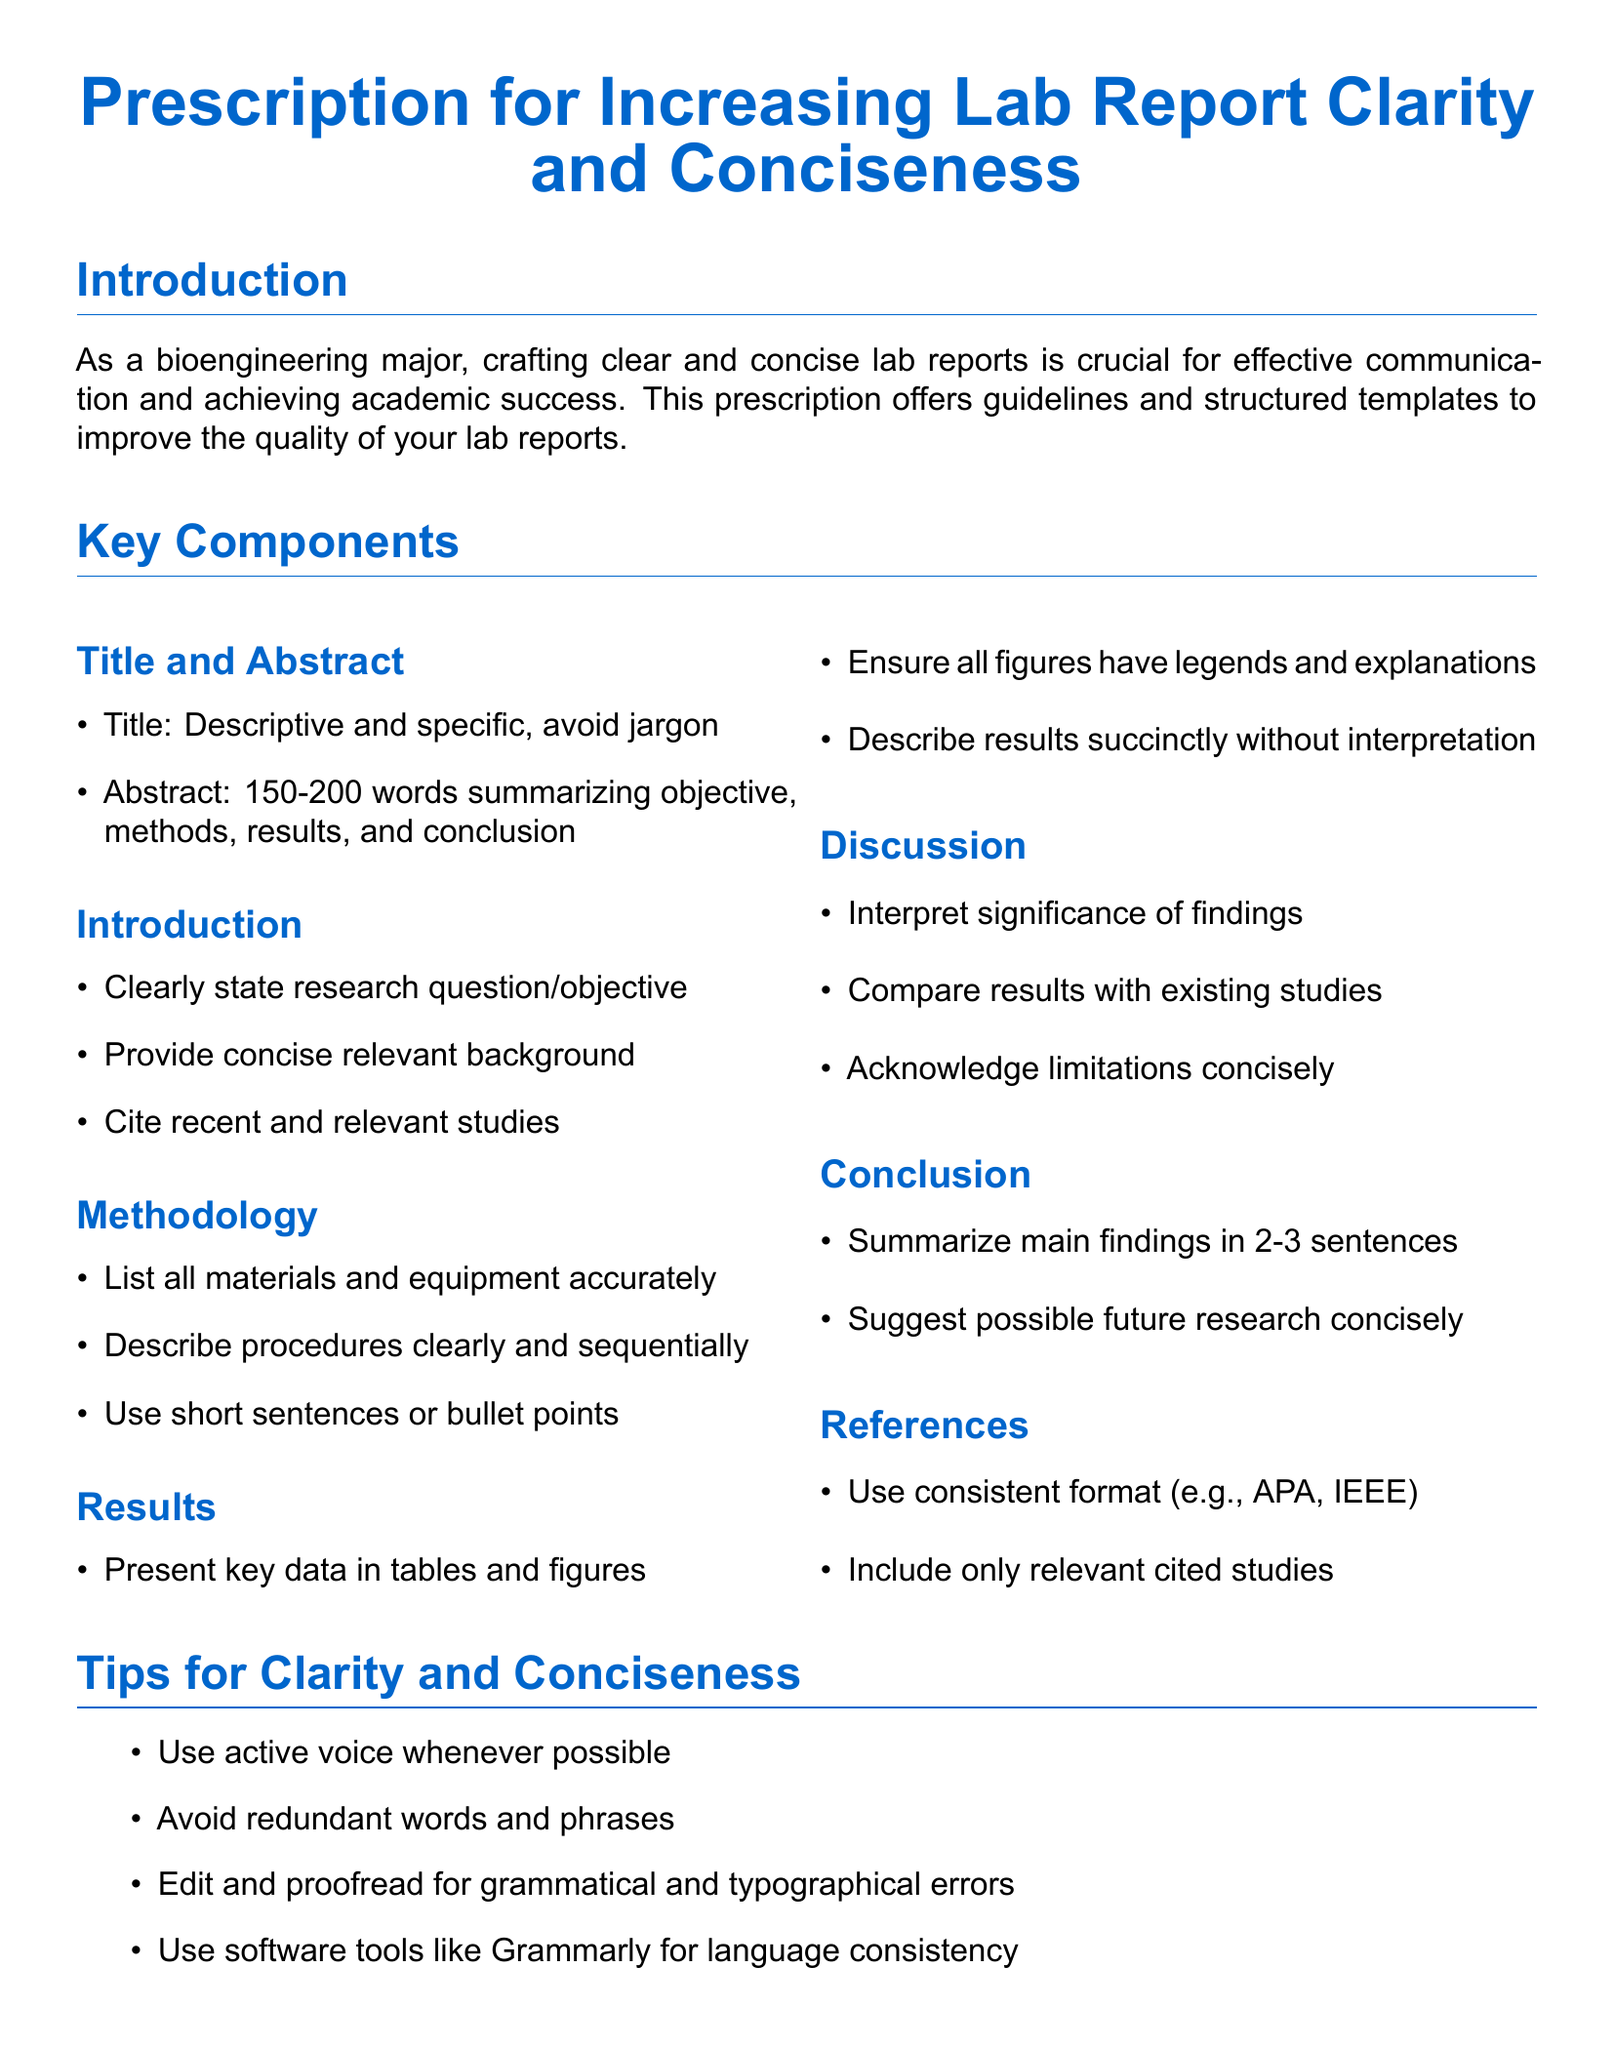What is the main focus of the prescription? The introduction states that the prescription is focused on improving clarity and conciseness in lab reports for bioengineering majors.
Answer: Clarity and conciseness What is the recommended word count for the abstract? The document specifies a word limit for the abstract section of the lab report.
Answer: 150-200 words What is one key component to include in the introduction section? The introduction should include a clearly stated research question or objective.
Answer: Research question How should results be presented according to the document? The document mentions that presenting key data in a specific format is essential for clarity.
Answer: Tables and figures What voice should be used to enhance clarity in writing? The tips section advises on a specific style preference for writing in the lab report.
Answer: Active voice Which guideline suggests proofreading for errors? One of the listed tips emphasizes the importance of a specific type of review for clarity and quality.
Answer: Edit and proofread What type of voice is recommended in the document for writing? The tips section provides guidance on the style of writing to improve communication effectiveness.
Answer: Active voice What is one citation format suggested for the references section? The guidelines specify a consistent format for citing sources in lab reports.
Answer: APA, IEEE 